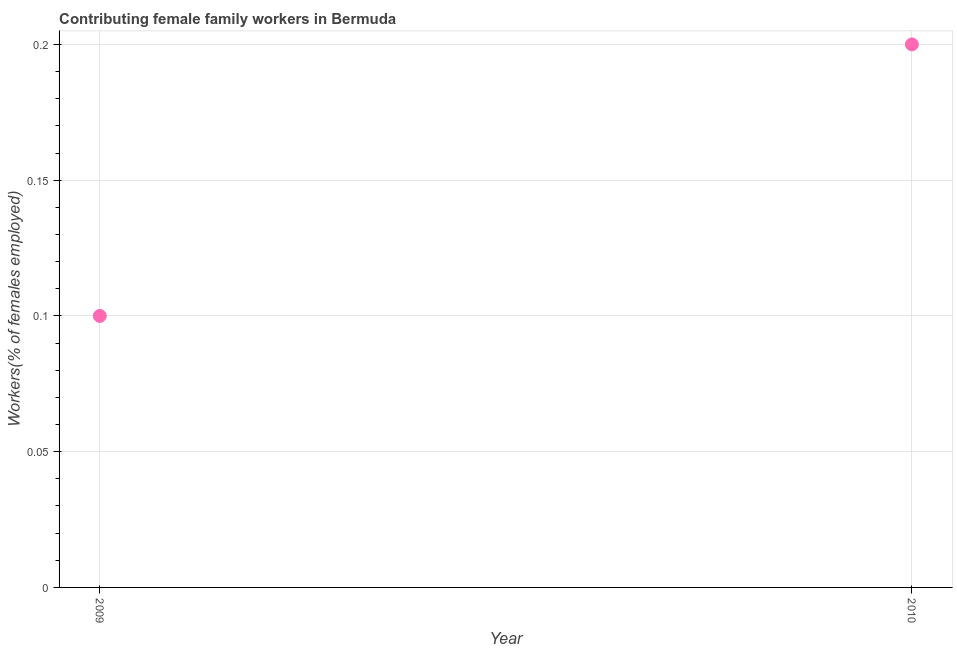What is the contributing female family workers in 2010?
Offer a very short reply. 0.2. Across all years, what is the maximum contributing female family workers?
Keep it short and to the point. 0.2. Across all years, what is the minimum contributing female family workers?
Keep it short and to the point. 0.1. What is the sum of the contributing female family workers?
Your answer should be compact. 0.3. What is the difference between the contributing female family workers in 2009 and 2010?
Offer a terse response. -0.1. What is the average contributing female family workers per year?
Give a very brief answer. 0.15. What is the median contributing female family workers?
Provide a short and direct response. 0.15. In how many years, is the contributing female family workers greater than 0.15000000000000002 %?
Make the answer very short. 1. Do a majority of the years between 2009 and 2010 (inclusive) have contributing female family workers greater than 0.11 %?
Your answer should be very brief. No. In how many years, is the contributing female family workers greater than the average contributing female family workers taken over all years?
Give a very brief answer. 1. Does the contributing female family workers monotonically increase over the years?
Give a very brief answer. Yes. How many dotlines are there?
Provide a short and direct response. 1. What is the title of the graph?
Your answer should be compact. Contributing female family workers in Bermuda. What is the label or title of the Y-axis?
Your answer should be very brief. Workers(% of females employed). What is the Workers(% of females employed) in 2009?
Offer a very short reply. 0.1. What is the Workers(% of females employed) in 2010?
Your response must be concise. 0.2. What is the ratio of the Workers(% of females employed) in 2009 to that in 2010?
Provide a short and direct response. 0.5. 